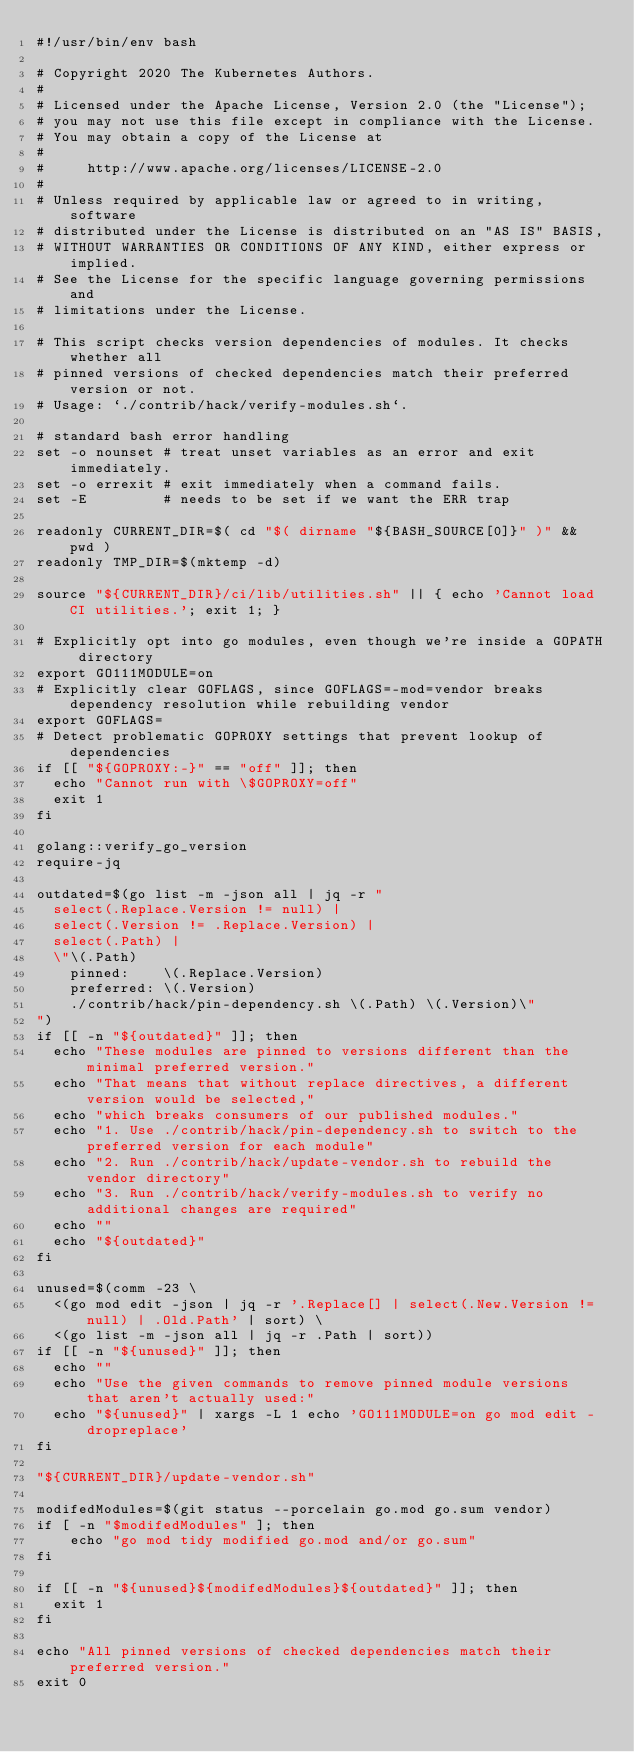Convert code to text. <code><loc_0><loc_0><loc_500><loc_500><_Bash_>#!/usr/bin/env bash

# Copyright 2020 The Kubernetes Authors.
#
# Licensed under the Apache License, Version 2.0 (the "License");
# you may not use this file except in compliance with the License.
# You may obtain a copy of the License at
#
#     http://www.apache.org/licenses/LICENSE-2.0
#
# Unless required by applicable law or agreed to in writing, software
# distributed under the License is distributed on an "AS IS" BASIS,
# WITHOUT WARRANTIES OR CONDITIONS OF ANY KIND, either express or implied.
# See the License for the specific language governing permissions and
# limitations under the License.

# This script checks version dependencies of modules. It checks whether all
# pinned versions of checked dependencies match their preferred version or not.
# Usage: `./contrib/hack/verify-modules.sh`.

# standard bash error handling
set -o nounset # treat unset variables as an error and exit immediately.
set -o errexit # exit immediately when a command fails.
set -E         # needs to be set if we want the ERR trap

readonly CURRENT_DIR=$( cd "$( dirname "${BASH_SOURCE[0]}" )" && pwd )
readonly TMP_DIR=$(mktemp -d)

source "${CURRENT_DIR}/ci/lib/utilities.sh" || { echo 'Cannot load CI utilities.'; exit 1; }

# Explicitly opt into go modules, even though we're inside a GOPATH directory
export GO111MODULE=on
# Explicitly clear GOFLAGS, since GOFLAGS=-mod=vendor breaks dependency resolution while rebuilding vendor
export GOFLAGS=
# Detect problematic GOPROXY settings that prevent lookup of dependencies
if [[ "${GOPROXY:-}" == "off" ]]; then
  echo "Cannot run with \$GOPROXY=off"
  exit 1
fi

golang::verify_go_version
require-jq

outdated=$(go list -m -json all | jq -r "
  select(.Replace.Version != null) |
  select(.Version != .Replace.Version) |
  select(.Path) |
  \"\(.Path)
    pinned:    \(.Replace.Version)
    preferred: \(.Version)
    ./contrib/hack/pin-dependency.sh \(.Path) \(.Version)\"
")
if [[ -n "${outdated}" ]]; then
  echo "These modules are pinned to versions different than the minimal preferred version."
  echo "That means that without replace directives, a different version would be selected,"
  echo "which breaks consumers of our published modules."
  echo "1. Use ./contrib/hack/pin-dependency.sh to switch to the preferred version for each module"
  echo "2. Run ./contrib/hack/update-vendor.sh to rebuild the vendor directory"
  echo "3. Run ./contrib/hack/verify-modules.sh to verify no additional changes are required"
  echo ""
  echo "${outdated}"
fi

unused=$(comm -23 \
  <(go mod edit -json | jq -r '.Replace[] | select(.New.Version != null) | .Old.Path' | sort) \
  <(go list -m -json all | jq -r .Path | sort))
if [[ -n "${unused}" ]]; then
  echo ""
  echo "Use the given commands to remove pinned module versions that aren't actually used:"
  echo "${unused}" | xargs -L 1 echo 'GO111MODULE=on go mod edit -dropreplace'
fi

"${CURRENT_DIR}/update-vendor.sh"

modifedModules=$(git status --porcelain go.mod go.sum vendor)
if [ -n "$modifedModules" ]; then
    echo "go mod tidy modified go.mod and/or go.sum"
fi

if [[ -n "${unused}${modifedModules}${outdated}" ]]; then
  exit 1
fi

echo "All pinned versions of checked dependencies match their preferred version."
exit 0</code> 